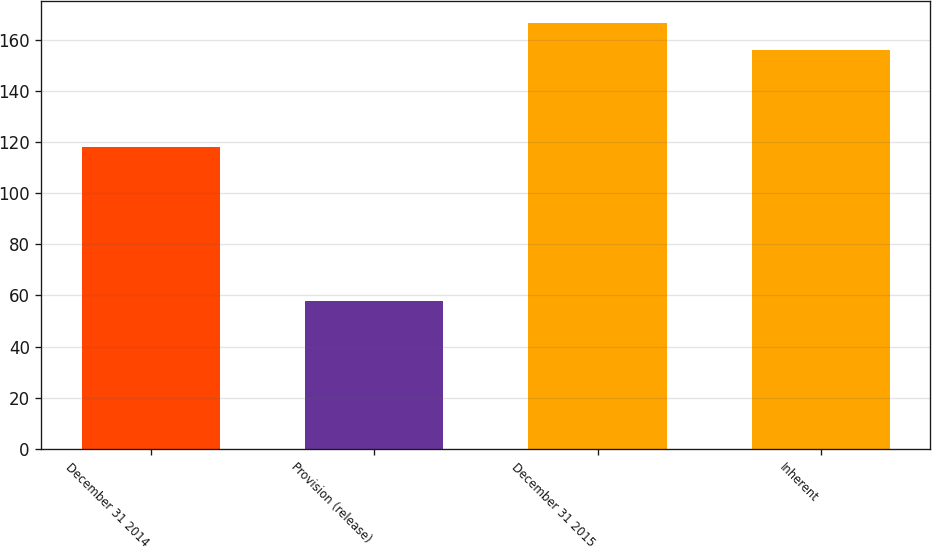<chart> <loc_0><loc_0><loc_500><loc_500><bar_chart><fcel>December 31 2014<fcel>Provision (release)<fcel>December 31 2015<fcel>Inherent<nl><fcel>118<fcel>58<fcel>166.8<fcel>156<nl></chart> 